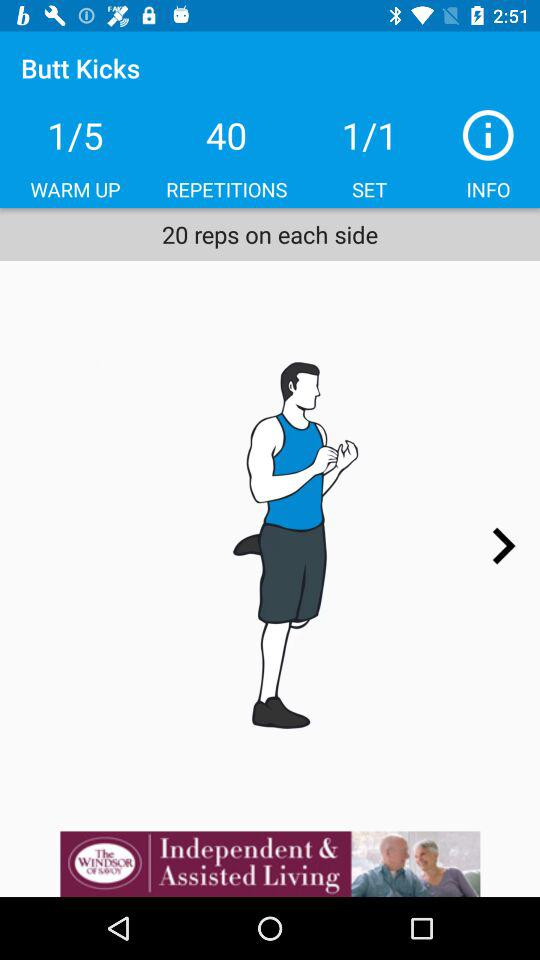At what number of exercises in the warm up are we currently? You are currently on exercise 1 in the warm up. 